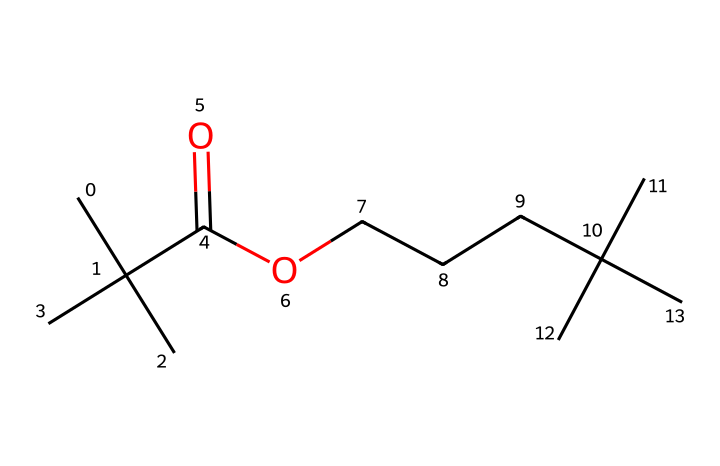What is the molecular formula of this compound? To find the molecular formula, count the number of each type of atom in the SMILES representation. The given SMILES indicates several carbon (C) and oxygen (O) atoms. Counting them carefully shows there are 20 carbon atoms and 2 oxygen atoms, giving a molecular formula of C20H40O2.
Answer: C20H40O2 How many carbon atoms are present in the structure? By examining the provided SMILES, the structure is broken down into its components and each carbon atom (C) is counted. The total number of carbon atoms adds up to 20.
Answer: 20 Is this compound a polyunsaturated polymer? The SMILES representation indicates the presence of double bonds, but after analyzing the structure, it shows no double bonds between carbon atoms, indicating saturation. Therefore, this compound is not polyunsaturated.
Answer: no What type of functional group is represented in this polymer? Looking at the SMILES, the structure exhibits a carboxylic acid functional group (-COOH), seen from the C(=O)O part of the molecule. This indicates that the polymer contains functional groups characteristic of carboxylic acids.
Answer: carboxylic acid Does this polymer structure suggest high viscosity? Considering the long-chain structure of the polymer and the presence of carbon atoms, it can be inferred that the large molecular weight and structure contribute to a higher viscosity, typical of synthetic inks.
Answer: yes What is the primary role of this polymer in ballpoint pens? This type of polymer is predominantly used in the ink formulation for ballpoint pens, helping to ensure smooth flow and a consistent writing experience while also aiding in drying time and preventing smudging.
Answer: ink formulation 